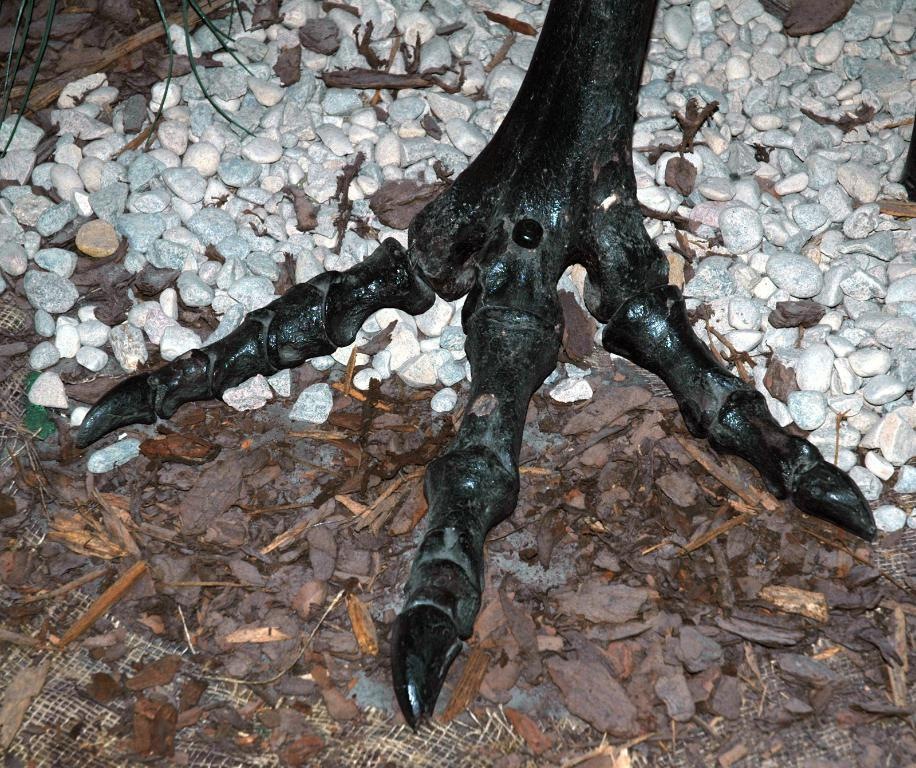What type of material is featured in the image? There is carved wood and wood pieces in the image. What other natural elements can be seen in the image? There are stones and a plant on the ground in the image. What type of error can be seen on the canvas in the image? There is no canvas present in the image, and therefore no errors can be observed. 